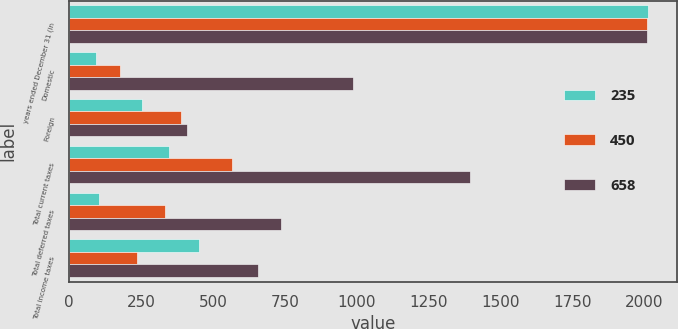Convert chart. <chart><loc_0><loc_0><loc_500><loc_500><stacked_bar_chart><ecel><fcel>years ended December 31 (in<fcel>Domestic<fcel>Foreign<fcel>Total current taxes<fcel>Total deferred taxes<fcel>Total income taxes<nl><fcel>235<fcel>2012<fcel>94<fcel>252<fcel>346<fcel>104<fcel>450<nl><fcel>450<fcel>2011<fcel>177<fcel>390<fcel>567<fcel>332<fcel>235<nl><fcel>658<fcel>2010<fcel>987<fcel>408<fcel>1395<fcel>737<fcel>658<nl></chart> 